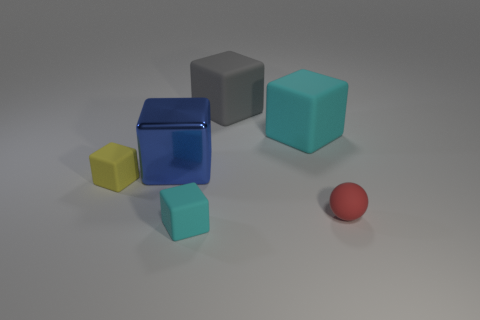What is the size of the cyan cube in front of the metallic cube that is on the left side of the cyan block that is behind the yellow block?
Provide a succinct answer. Small. There is a cyan block that is in front of the big cyan cube; what is its size?
Provide a short and direct response. Small. The tiny cyan thing that is the same material as the gray thing is what shape?
Make the answer very short. Cube. Are the cyan block that is in front of the big blue metallic cube and the gray object made of the same material?
Your answer should be very brief. Yes. How many other things are there of the same material as the tiny yellow block?
Ensure brevity in your answer.  4. What number of things are either small matte blocks that are in front of the large gray thing or objects to the left of the large cyan thing?
Give a very brief answer. 4. Does the big metallic object on the left side of the small matte ball have the same shape as the tiny yellow object behind the ball?
Make the answer very short. Yes. There is a red matte thing that is the same size as the yellow matte object; what is its shape?
Your answer should be very brief. Sphere. What number of matte objects are cyan objects or blue objects?
Provide a short and direct response. 2. Are the tiny block that is in front of the small yellow rubber cube and the cyan cube that is behind the small red thing made of the same material?
Your response must be concise. Yes. 